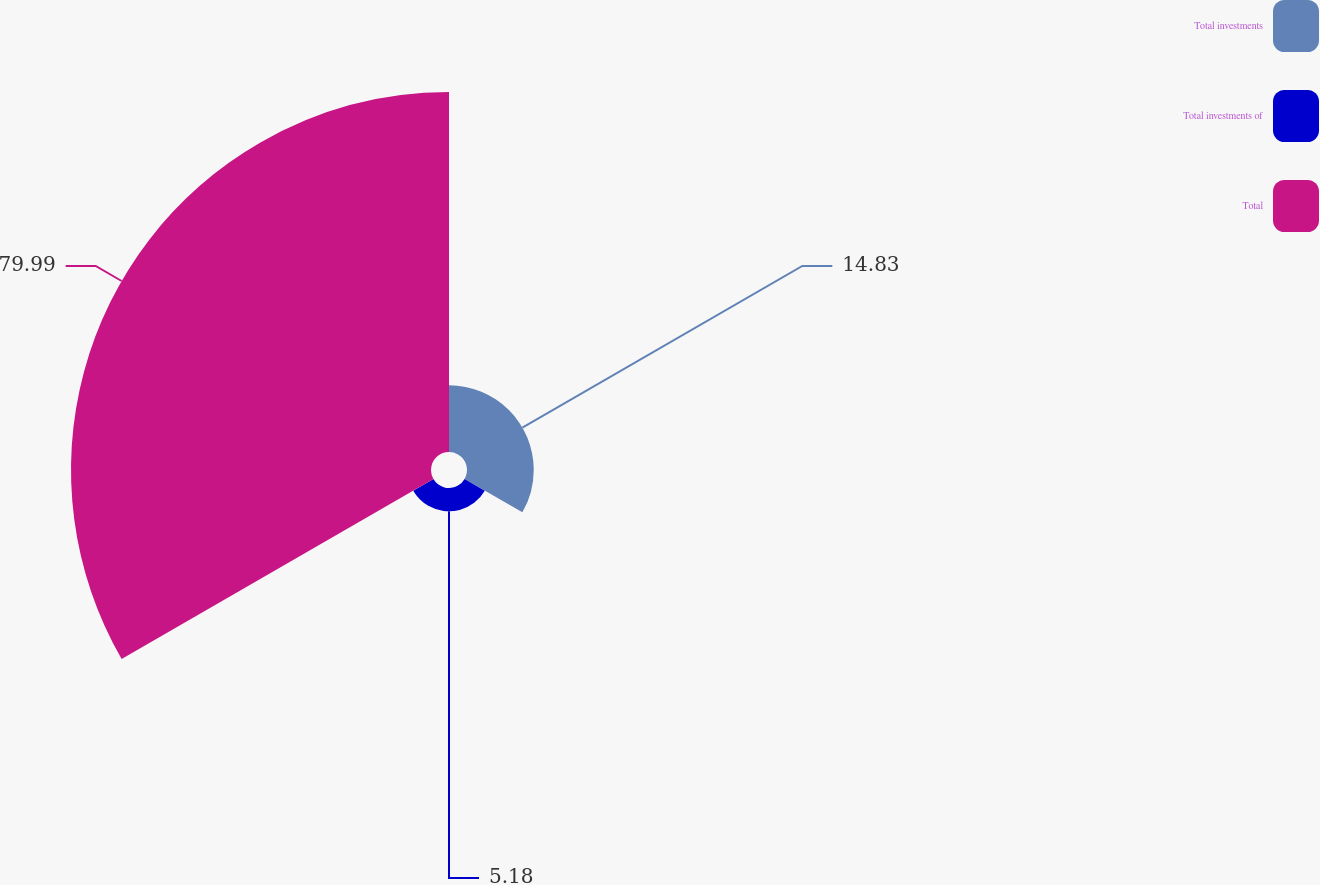Convert chart to OTSL. <chart><loc_0><loc_0><loc_500><loc_500><pie_chart><fcel>Total investments<fcel>Total investments of<fcel>Total<nl><fcel>14.83%<fcel>5.18%<fcel>79.99%<nl></chart> 